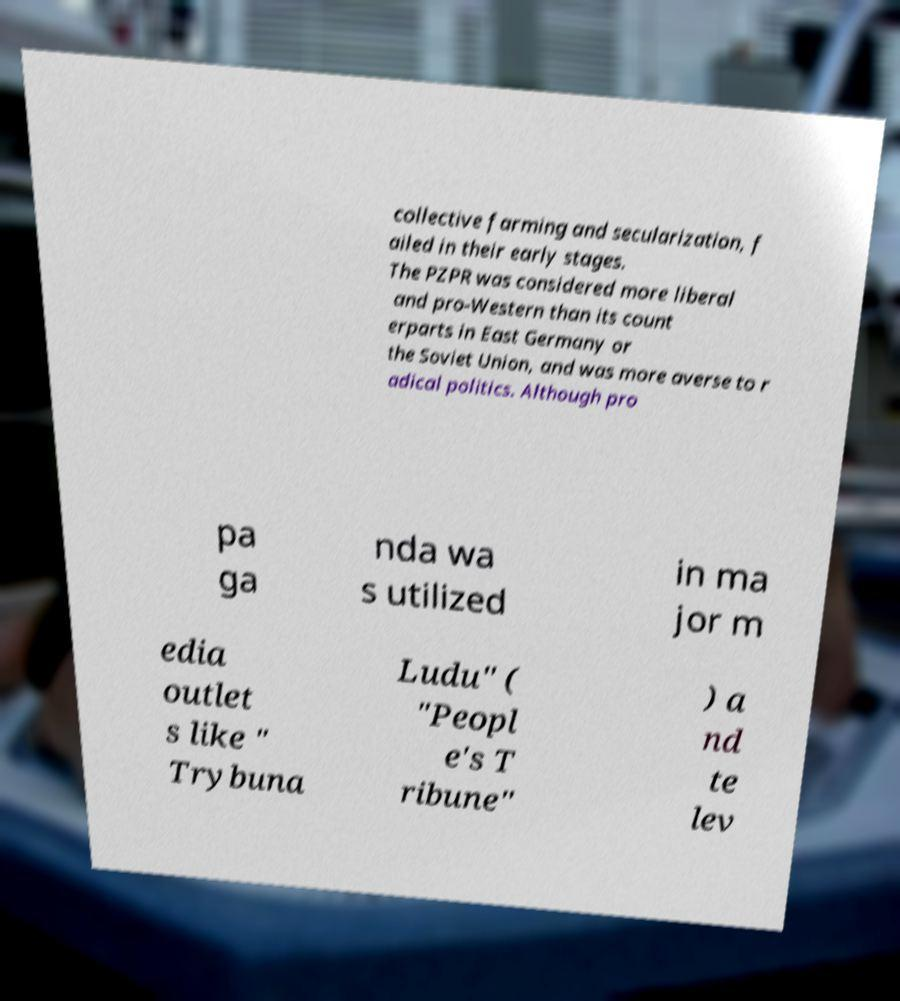I need the written content from this picture converted into text. Can you do that? collective farming and secularization, f ailed in their early stages. The PZPR was considered more liberal and pro-Western than its count erparts in East Germany or the Soviet Union, and was more averse to r adical politics. Although pro pa ga nda wa s utilized in ma jor m edia outlet s like " Trybuna Ludu" ( "Peopl e's T ribune" ) a nd te lev 